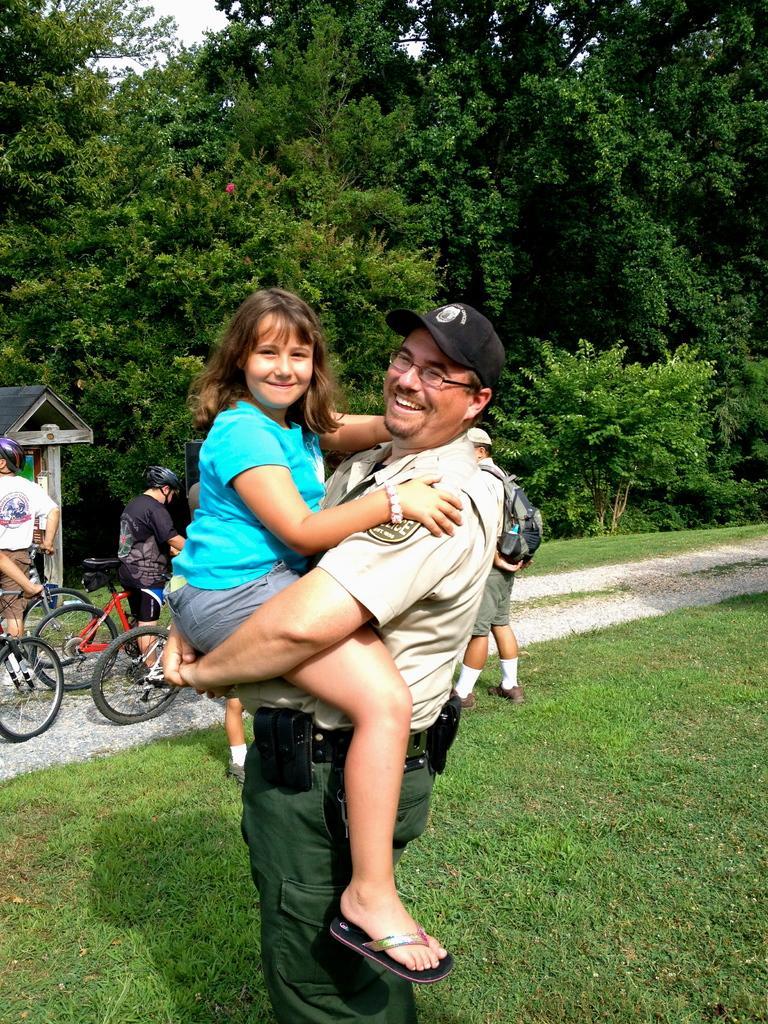In one or two sentences, can you explain what this image depicts? In this picture there is a man holding a girl in his hands. There are few people who are riding a bicycle. There is some grass on the ground and some trees at the background. 